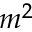Convert formula to latex. <formula><loc_0><loc_0><loc_500><loc_500>m ^ { 2 }</formula> 